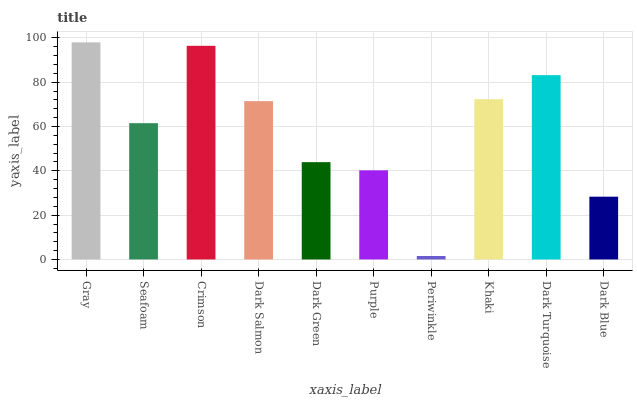Is Periwinkle the minimum?
Answer yes or no. Yes. Is Gray the maximum?
Answer yes or no. Yes. Is Seafoam the minimum?
Answer yes or no. No. Is Seafoam the maximum?
Answer yes or no. No. Is Gray greater than Seafoam?
Answer yes or no. Yes. Is Seafoam less than Gray?
Answer yes or no. Yes. Is Seafoam greater than Gray?
Answer yes or no. No. Is Gray less than Seafoam?
Answer yes or no. No. Is Dark Salmon the high median?
Answer yes or no. Yes. Is Seafoam the low median?
Answer yes or no. Yes. Is Khaki the high median?
Answer yes or no. No. Is Dark Blue the low median?
Answer yes or no. No. 